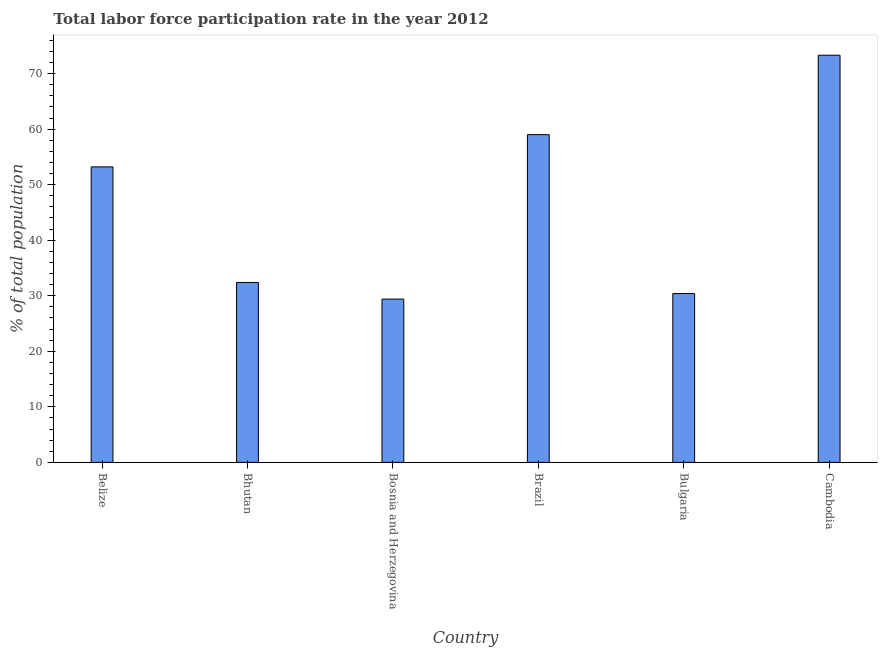Does the graph contain any zero values?
Make the answer very short. No. What is the title of the graph?
Provide a succinct answer. Total labor force participation rate in the year 2012. What is the label or title of the X-axis?
Provide a succinct answer. Country. What is the label or title of the Y-axis?
Ensure brevity in your answer.  % of total population. What is the total labor force participation rate in Bosnia and Herzegovina?
Ensure brevity in your answer.  29.4. Across all countries, what is the maximum total labor force participation rate?
Provide a succinct answer. 73.3. Across all countries, what is the minimum total labor force participation rate?
Ensure brevity in your answer.  29.4. In which country was the total labor force participation rate maximum?
Provide a succinct answer. Cambodia. In which country was the total labor force participation rate minimum?
Provide a short and direct response. Bosnia and Herzegovina. What is the sum of the total labor force participation rate?
Your answer should be compact. 277.7. What is the difference between the total labor force participation rate in Bosnia and Herzegovina and Brazil?
Your answer should be very brief. -29.6. What is the average total labor force participation rate per country?
Offer a terse response. 46.28. What is the median total labor force participation rate?
Make the answer very short. 42.8. What is the ratio of the total labor force participation rate in Bhutan to that in Brazil?
Your response must be concise. 0.55. Is the difference between the total labor force participation rate in Belize and Bulgaria greater than the difference between any two countries?
Give a very brief answer. No. What is the difference between the highest and the lowest total labor force participation rate?
Your response must be concise. 43.9. How many bars are there?
Keep it short and to the point. 6. What is the % of total population in Belize?
Keep it short and to the point. 53.2. What is the % of total population in Bhutan?
Offer a terse response. 32.4. What is the % of total population in Bosnia and Herzegovina?
Provide a succinct answer. 29.4. What is the % of total population in Bulgaria?
Provide a short and direct response. 30.4. What is the % of total population in Cambodia?
Your answer should be very brief. 73.3. What is the difference between the % of total population in Belize and Bhutan?
Offer a very short reply. 20.8. What is the difference between the % of total population in Belize and Bosnia and Herzegovina?
Offer a terse response. 23.8. What is the difference between the % of total population in Belize and Bulgaria?
Your response must be concise. 22.8. What is the difference between the % of total population in Belize and Cambodia?
Keep it short and to the point. -20.1. What is the difference between the % of total population in Bhutan and Brazil?
Provide a succinct answer. -26.6. What is the difference between the % of total population in Bhutan and Cambodia?
Offer a terse response. -40.9. What is the difference between the % of total population in Bosnia and Herzegovina and Brazil?
Offer a very short reply. -29.6. What is the difference between the % of total population in Bosnia and Herzegovina and Bulgaria?
Keep it short and to the point. -1. What is the difference between the % of total population in Bosnia and Herzegovina and Cambodia?
Your answer should be very brief. -43.9. What is the difference between the % of total population in Brazil and Bulgaria?
Your answer should be very brief. 28.6. What is the difference between the % of total population in Brazil and Cambodia?
Your answer should be very brief. -14.3. What is the difference between the % of total population in Bulgaria and Cambodia?
Your response must be concise. -42.9. What is the ratio of the % of total population in Belize to that in Bhutan?
Your response must be concise. 1.64. What is the ratio of the % of total population in Belize to that in Bosnia and Herzegovina?
Ensure brevity in your answer.  1.81. What is the ratio of the % of total population in Belize to that in Brazil?
Offer a terse response. 0.9. What is the ratio of the % of total population in Belize to that in Bulgaria?
Keep it short and to the point. 1.75. What is the ratio of the % of total population in Belize to that in Cambodia?
Keep it short and to the point. 0.73. What is the ratio of the % of total population in Bhutan to that in Bosnia and Herzegovina?
Your answer should be compact. 1.1. What is the ratio of the % of total population in Bhutan to that in Brazil?
Make the answer very short. 0.55. What is the ratio of the % of total population in Bhutan to that in Bulgaria?
Your response must be concise. 1.07. What is the ratio of the % of total population in Bhutan to that in Cambodia?
Give a very brief answer. 0.44. What is the ratio of the % of total population in Bosnia and Herzegovina to that in Brazil?
Provide a succinct answer. 0.5. What is the ratio of the % of total population in Bosnia and Herzegovina to that in Cambodia?
Your answer should be very brief. 0.4. What is the ratio of the % of total population in Brazil to that in Bulgaria?
Your answer should be compact. 1.94. What is the ratio of the % of total population in Brazil to that in Cambodia?
Your answer should be very brief. 0.81. What is the ratio of the % of total population in Bulgaria to that in Cambodia?
Your answer should be very brief. 0.41. 